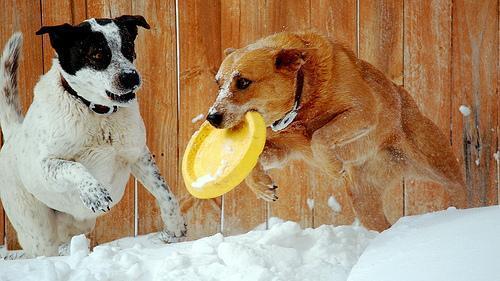How many dogs are pictured?
Give a very brief answer. 2. 